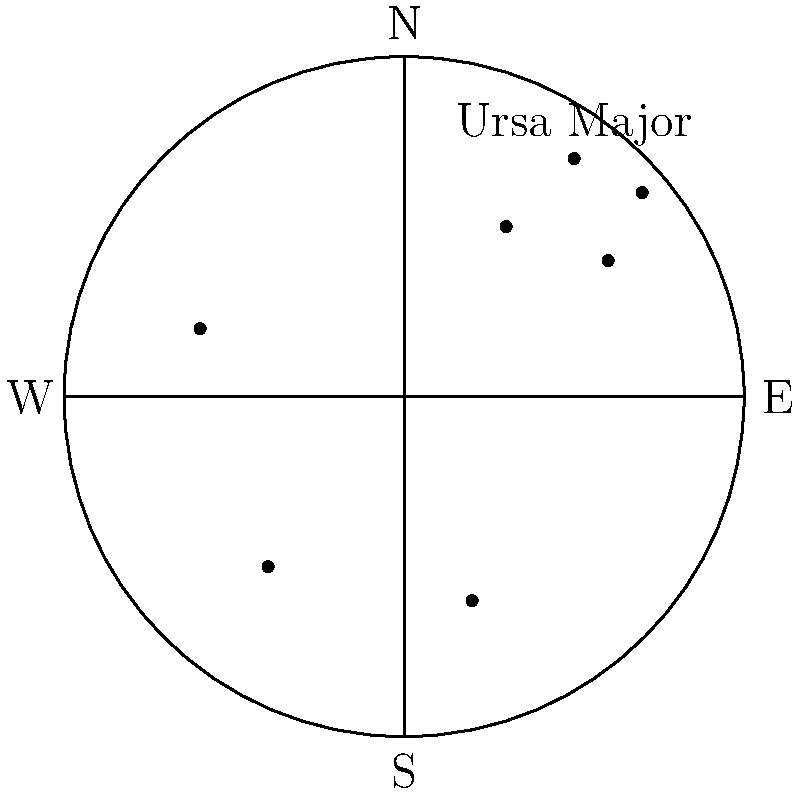Using the provided star chart representing the night sky in China, which major constellation is prominently visible? To identify the constellation visible from China using the given star chart, follow these steps:

1. Orient yourself with the chart:
   - The circle represents the entire visible sky.
   - Cardinal directions are marked (N, S, E, W).

2. Locate the group of stars:
   - There's a distinct group of four stars in the upper-right quadrant.

3. Identify the constellation:
   - This group of stars is labeled "Ursa Major" on the chart.

4. Consider the context:
   - Ursa Major, also known as the Great Bear, is indeed visible from China.
   - It's a circumpolar constellation in the Northern Hemisphere, meaning it's visible year-round from northern latitudes.

5. Verify the answer:
   - The question asks for a "major constellation," and Ursa Major is one of the most recognizable constellations in the night sky.

Therefore, based on the star chart provided, the major constellation prominently visible from China is Ursa Major.
Answer: Ursa Major 